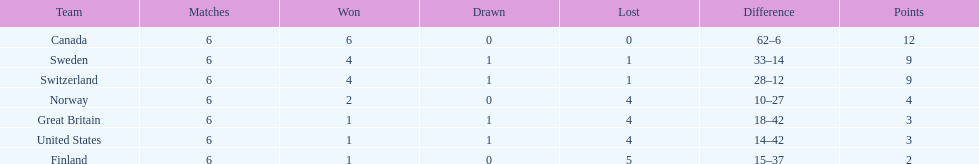How many teams won at least 4 matches? 3. Write the full table. {'header': ['Team', 'Matches', 'Won', 'Drawn', 'Lost', 'Difference', 'Points'], 'rows': [['Canada', '6', '6', '0', '0', '62–6', '12'], ['Sweden', '6', '4', '1', '1', '33–14', '9'], ['Switzerland', '6', '4', '1', '1', '28–12', '9'], ['Norway', '6', '2', '0', '4', '10–27', '4'], ['Great Britain', '6', '1', '1', '4', '18–42', '3'], ['United States', '6', '1', '1', '4', '14–42', '3'], ['Finland', '6', '1', '0', '5', '15–37', '2']]} 